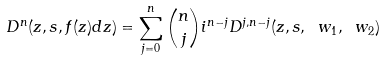<formula> <loc_0><loc_0><loc_500><loc_500>D ^ { n } ( z , s , f ( z ) d z ) = \sum _ { j = 0 } ^ { n } \binom { n } { j } i ^ { n - j } D ^ { j , n - j } ( z , s , \ w _ { 1 } , \ w _ { 2 } )</formula> 